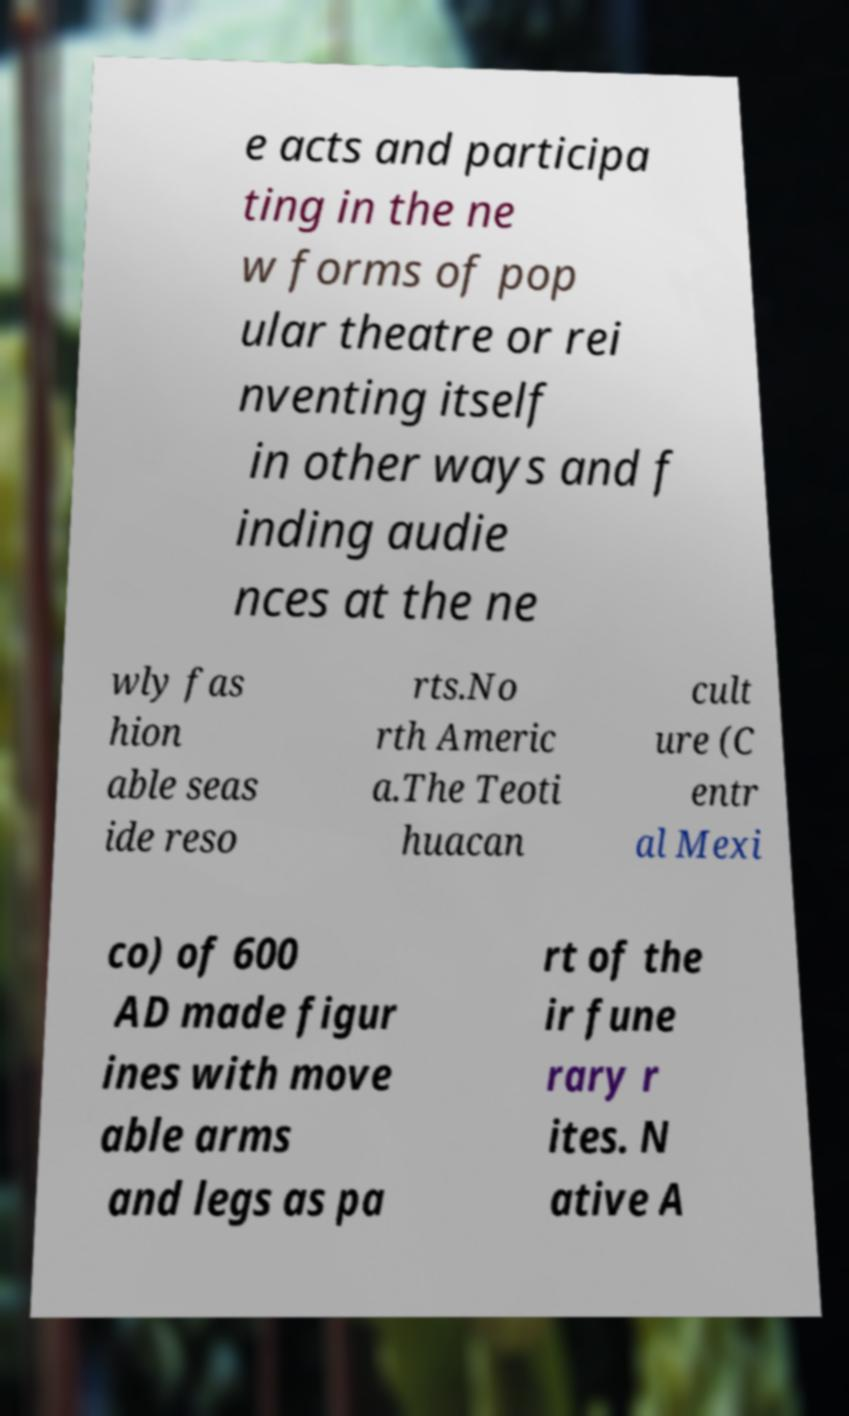Please read and relay the text visible in this image. What does it say? e acts and participa ting in the ne w forms of pop ular theatre or rei nventing itself in other ways and f inding audie nces at the ne wly fas hion able seas ide reso rts.No rth Americ a.The Teoti huacan cult ure (C entr al Mexi co) of 600 AD made figur ines with move able arms and legs as pa rt of the ir fune rary r ites. N ative A 